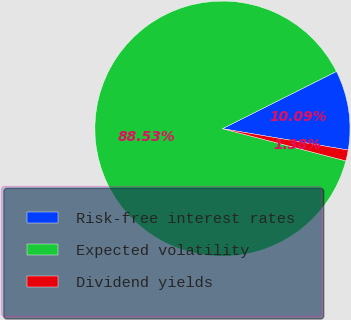Convert chart to OTSL. <chart><loc_0><loc_0><loc_500><loc_500><pie_chart><fcel>Risk-free interest rates<fcel>Expected volatility<fcel>Dividend yields<nl><fcel>10.09%<fcel>88.53%<fcel>1.38%<nl></chart> 